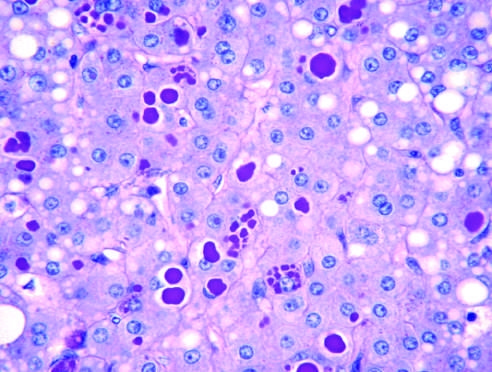what stain after diastase digestion of the liver?
Answer the question using a single word or phrase. Periodic acid-schiff (pas) 